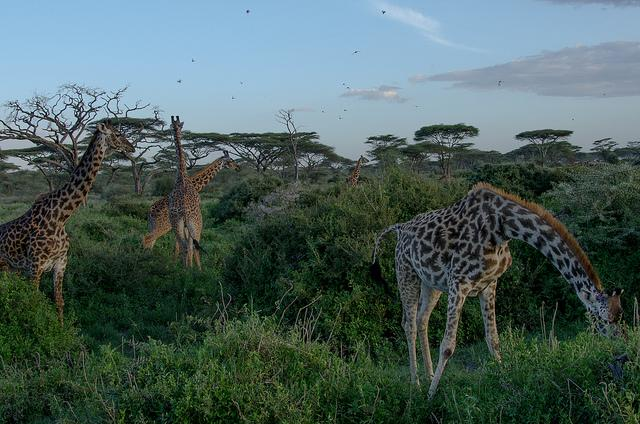How many giraffes can clearly be seen grazing in the area?

Choices:
A) five
B) six
C) four
D) seven five 